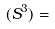<formula> <loc_0><loc_0><loc_500><loc_500>( S ^ { 3 } ) =</formula> 